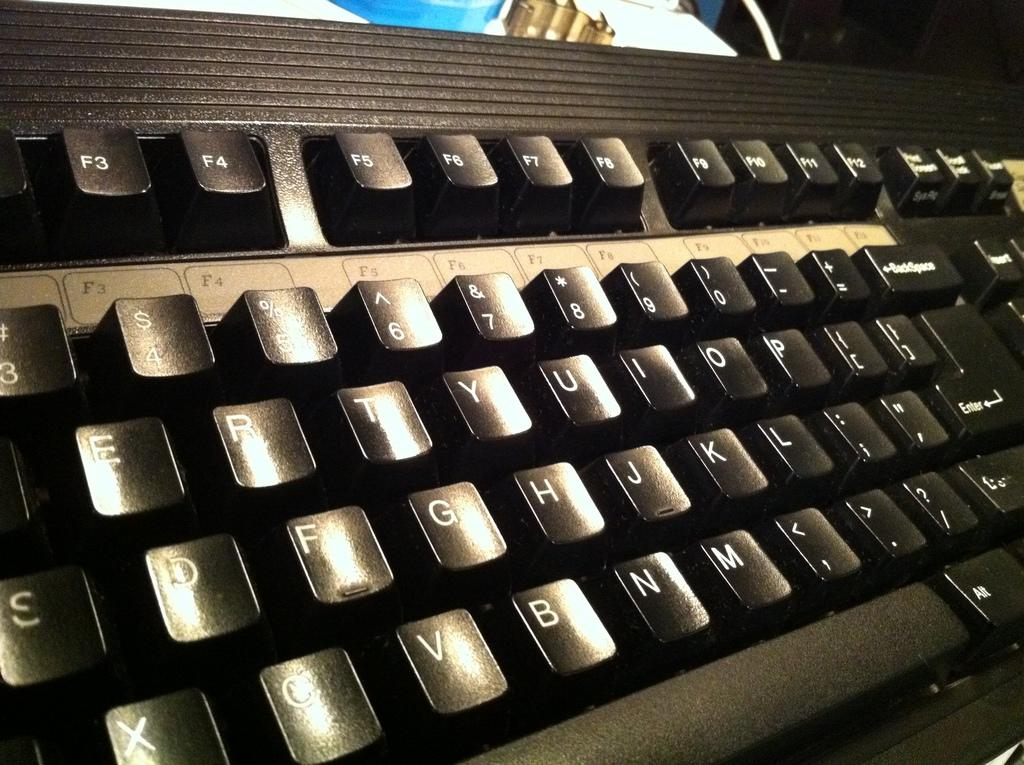<image>
Present a compact description of the photo's key features. A black keyboard with reflective keys that say Backspace and Enter. 